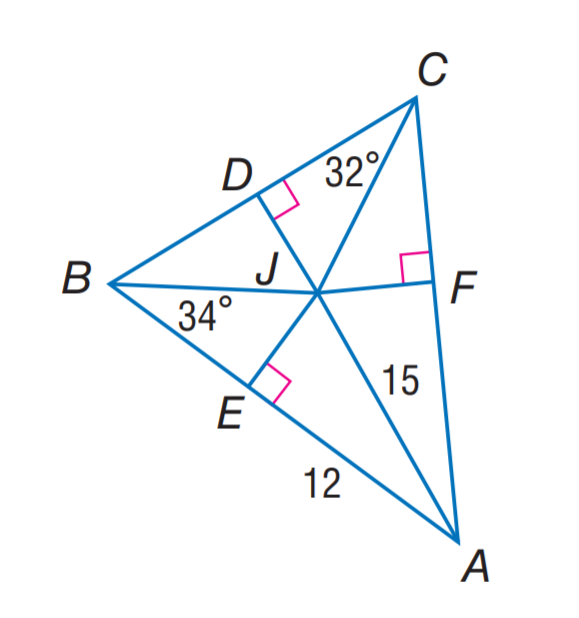Answer the mathemtical geometry problem and directly provide the correct option letter.
Question: J is the incenter of \angle A B C. Find J F.
Choices: A: 9 B: 12 C: 15 D: 32 A 